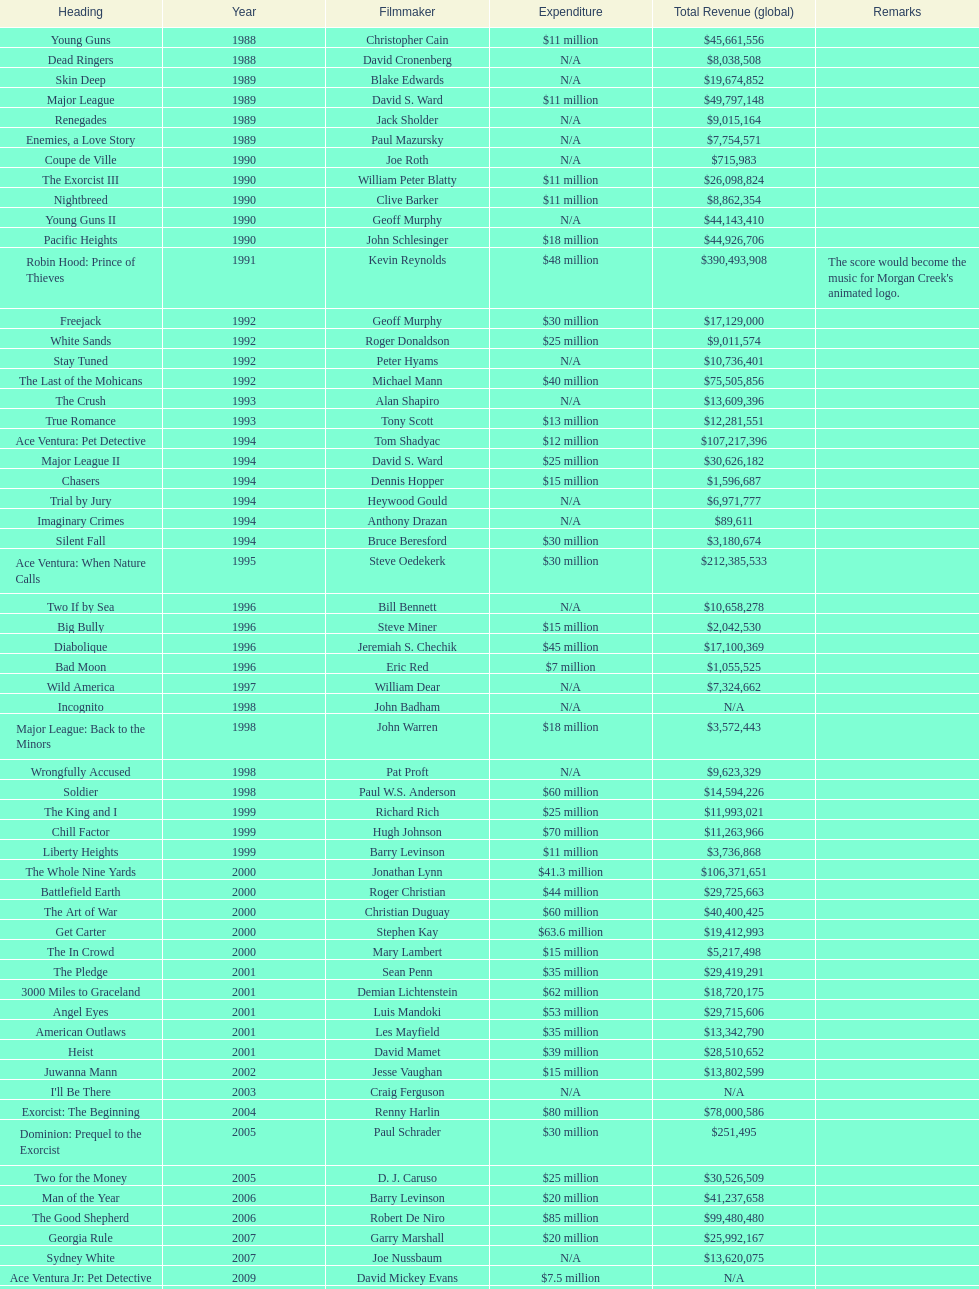How many movies were there in 1990? 5. 